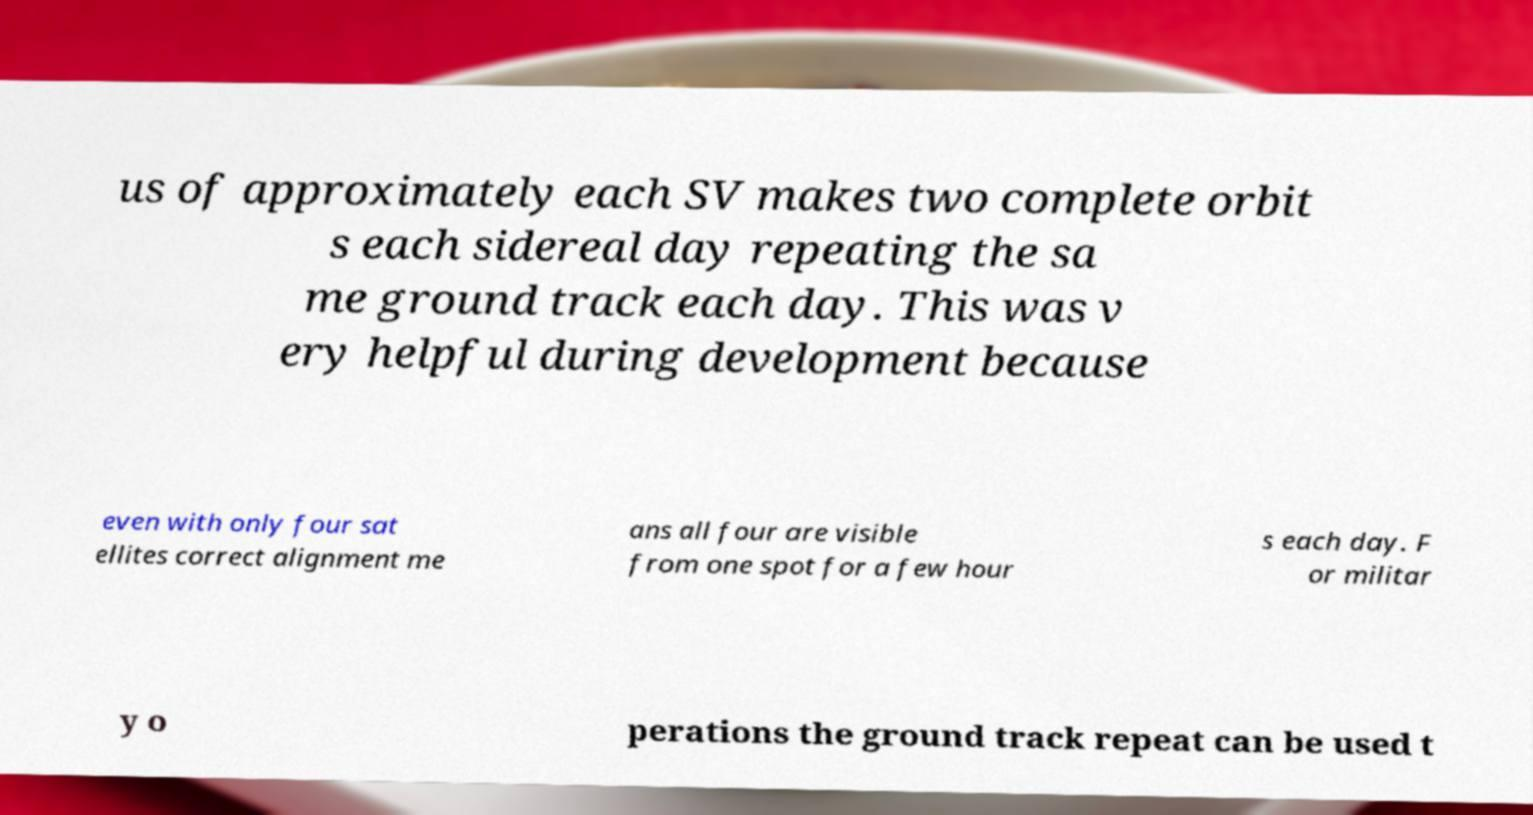What messages or text are displayed in this image? I need them in a readable, typed format. us of approximately each SV makes two complete orbit s each sidereal day repeating the sa me ground track each day. This was v ery helpful during development because even with only four sat ellites correct alignment me ans all four are visible from one spot for a few hour s each day. F or militar y o perations the ground track repeat can be used t 